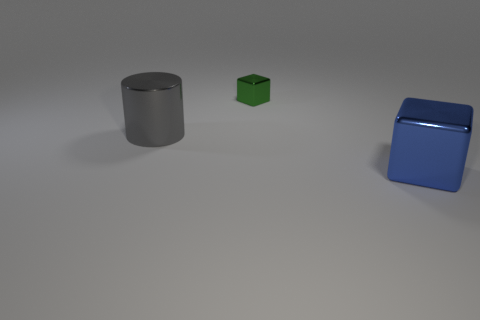Add 3 large purple cylinders. How many objects exist? 6 Subtract all cylinders. How many objects are left? 2 Subtract all green things. Subtract all large cyan cylinders. How many objects are left? 2 Add 3 big cylinders. How many big cylinders are left? 4 Add 1 big red shiny cylinders. How many big red shiny cylinders exist? 1 Subtract 0 cyan cubes. How many objects are left? 3 